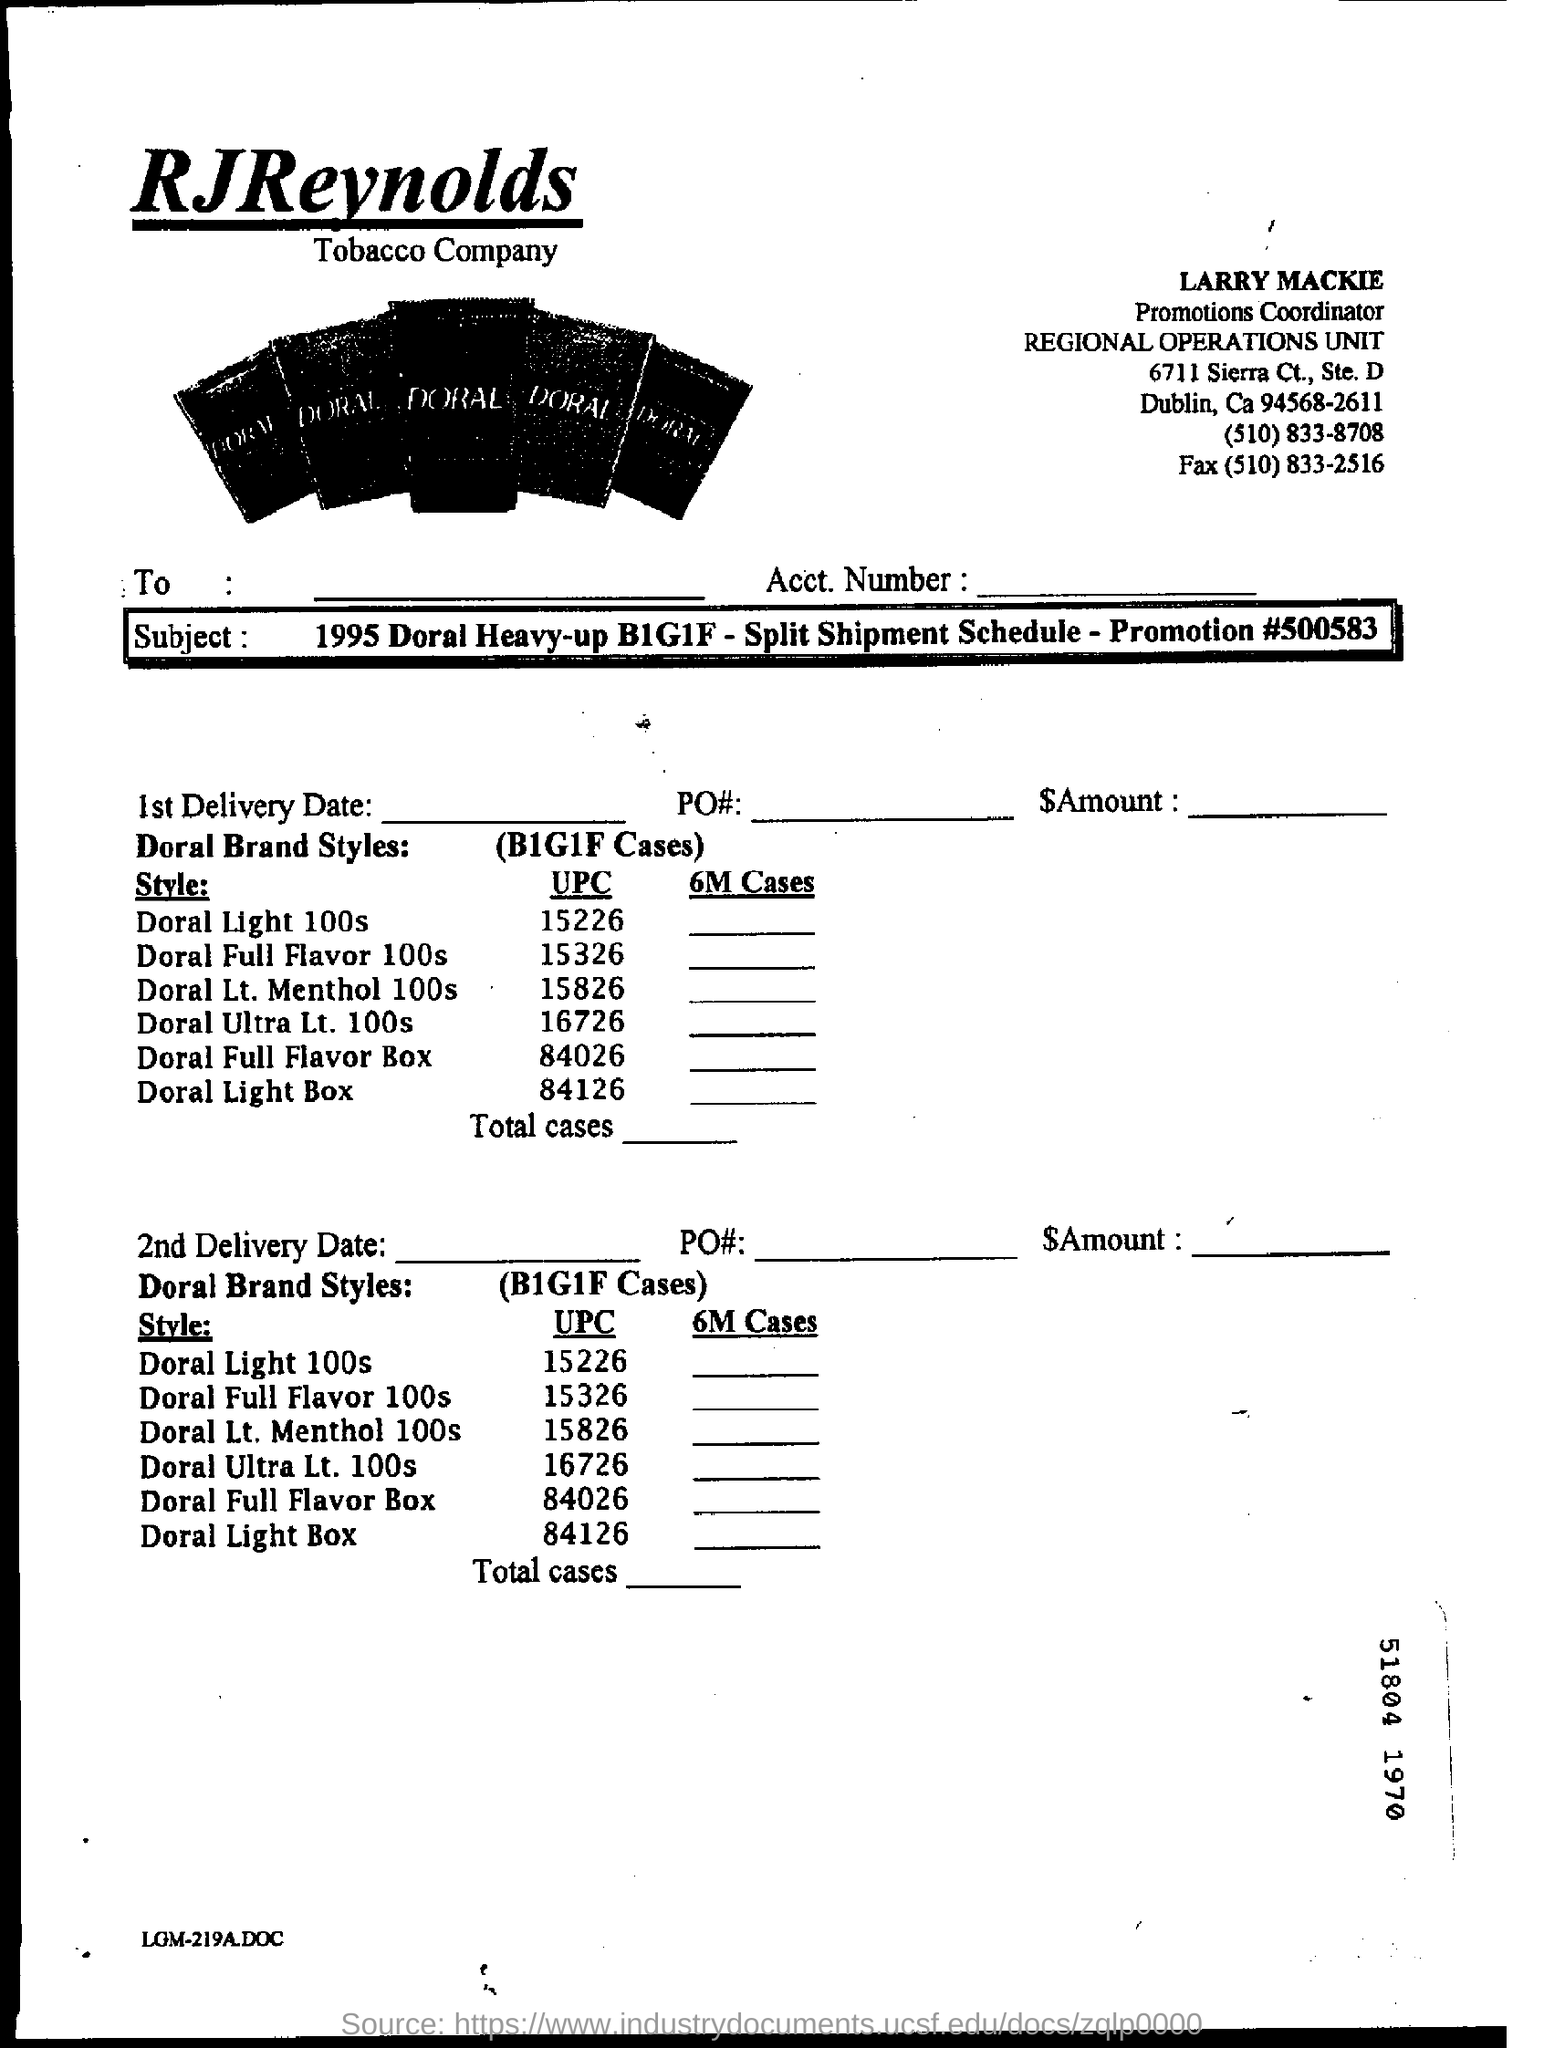Which Tobacco Company is mentioned in the form?
Keep it short and to the point. RJ Reynolds. Who is the Promotions coordinator?
Provide a succinct answer. Larry mackie. What is the fax number mentioned?
Offer a very short reply. (510) 833-2516. Which Doral brand style is to be delivered?
Offer a very short reply. B1G1F Cases. What is the promotion number?
Offer a very short reply. 500583. 